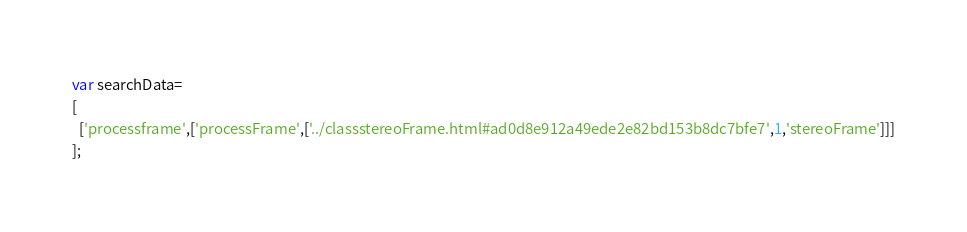<code> <loc_0><loc_0><loc_500><loc_500><_JavaScript_>var searchData=
[
  ['processframe',['processFrame',['../classstereoFrame.html#ad0d8e912a49ede2e82bd153b8dc7bfe7',1,'stereoFrame']]]
];
</code> 